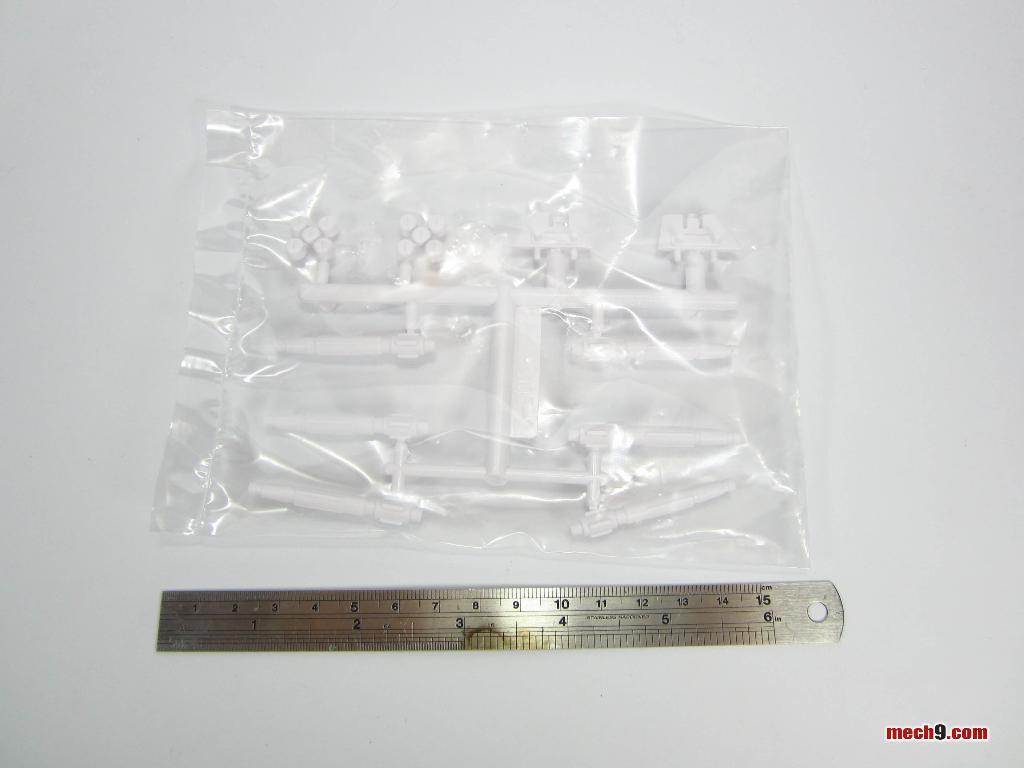What type of scale is visible in the image? There is a stainless steel scale in the image. What is contained in the packet in the image? There are plastic objects in a packet in the image. On what surface are the objects placed? The objects are placed on a white surface. How is the glue being used in the image? There is no glue present in the image. What type of ray is visible in the image? There is no ray visible in the image. 